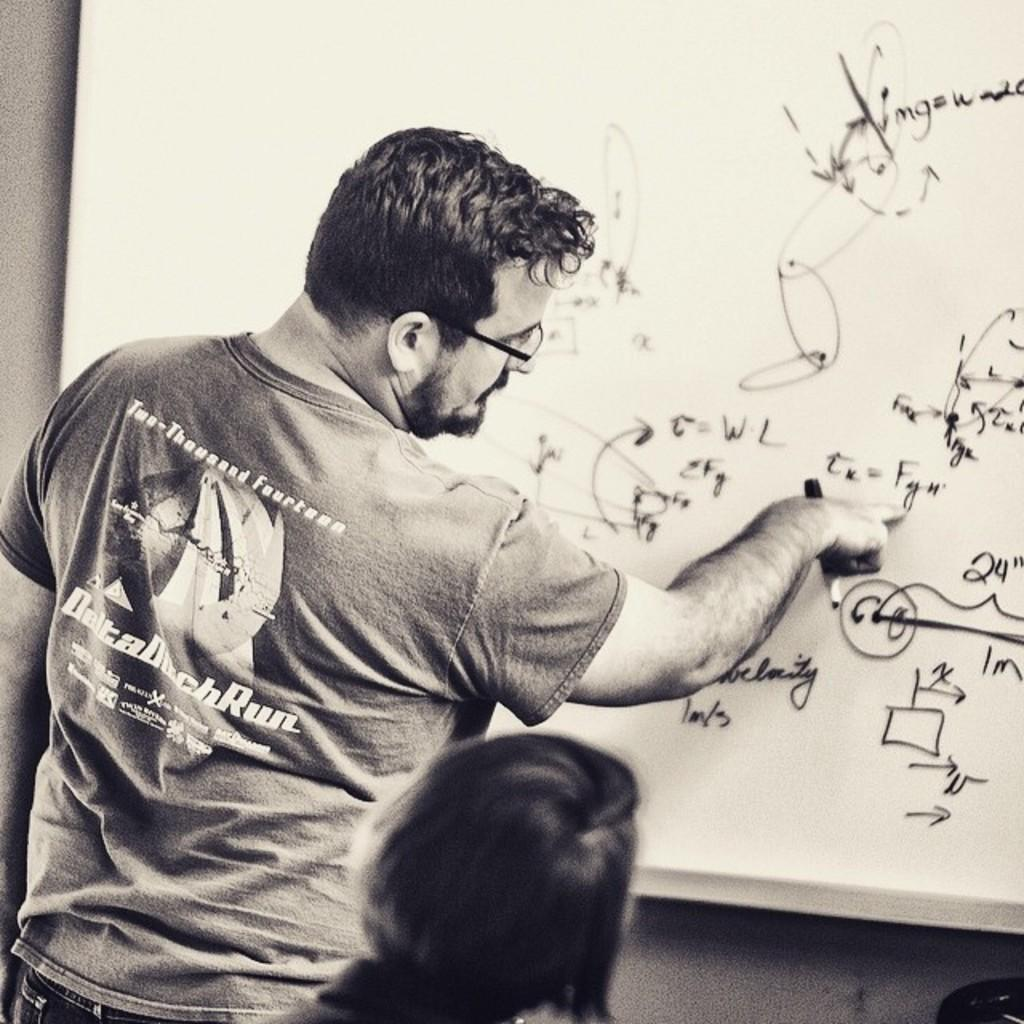<image>
Relay a brief, clear account of the picture shown. a man in a Two Thousand Fourteen shirt writes on a whiteboard 